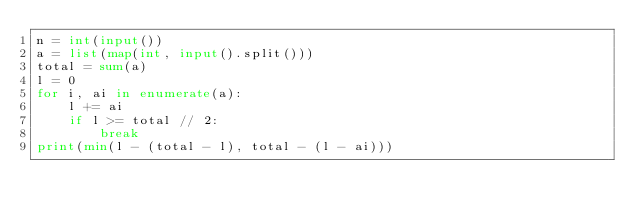Convert code to text. <code><loc_0><loc_0><loc_500><loc_500><_Python_>n = int(input())
a = list(map(int, input().split()))
total = sum(a)
l = 0
for i, ai in enumerate(a):
    l += ai
    if l >= total // 2:
        break
print(min(l - (total - l), total - (l - ai)))
</code> 